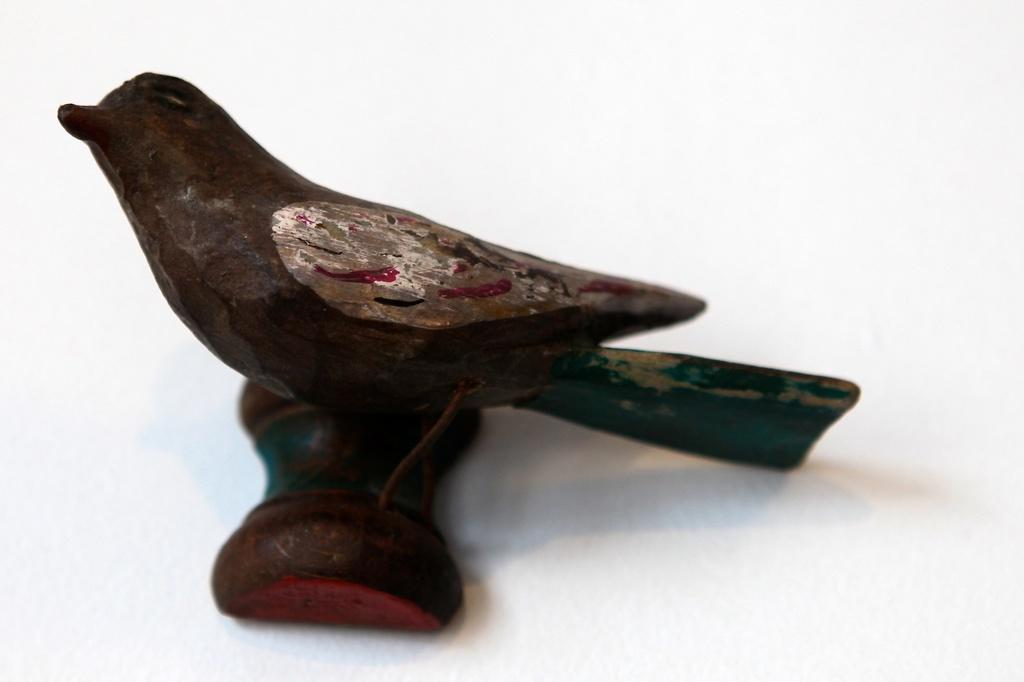What type of figurine is present in the image? There is a figurine of a bird in the image. What is the bird figurine placed on or near? There is a surface at the bottom of the image. What type of pain is the bird experiencing in the image? There is no indication in the image that the bird is experiencing any pain. 